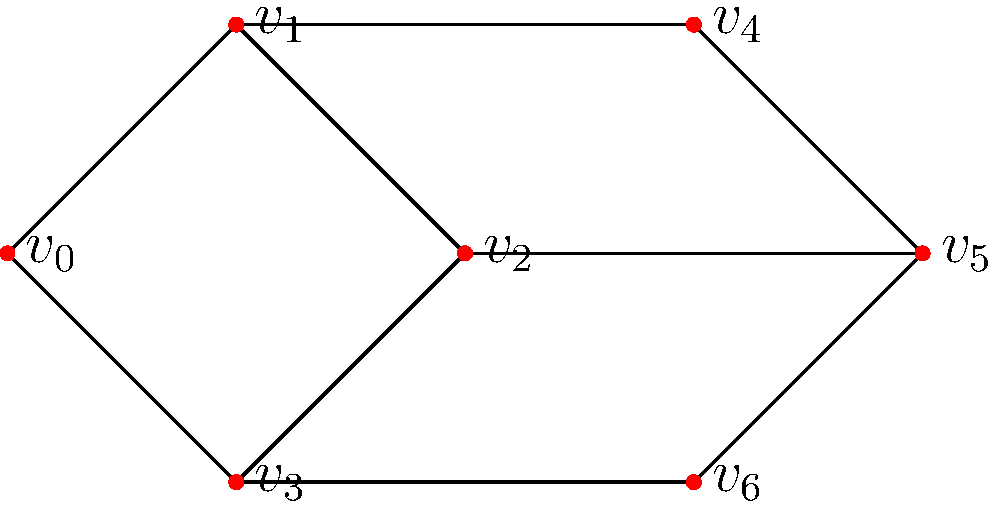In the network of cultural heritage sites shown above, what is the minimum number of sites that need to be protected to ensure that removing them would disconnect the network into at least three components? To solve this problem, we need to identify the minimum cut set that would disconnect the graph into at least three components. Let's approach this step-by-step:

1. First, observe the structure of the graph. It consists of 7 vertices (cultural heritage sites) connected by edges (connections between sites).

2. To disconnect the graph into at least three components, we need to remove vertices in a way that leaves at least three separate, unconnected subgraphs.

3. Looking at the graph, we can see that vertices $v_1$, $v_2$, and $v_3$ form a central "triangle" that connects the rest of the graph.

4. If we remove $v_1$ and $v_2$, the graph will be split into three components:
   - Component 1: $v_0$
   - Component 2: $v_3$, $v_6$
   - Component 3: $v_4$, $v_5$

5. This is the minimum number of vertices that need to be removed to achieve the desired result. Removing any single vertex would not split the graph into three components.

6. Therefore, the minimum number of sites that need to be protected to ensure that removing them would disconnect the network into at least three components is 2.

This solution represents the critical points in the cultural heritage network that, if compromised, would significantly disrupt the connectivity of the sites.
Answer: 2 